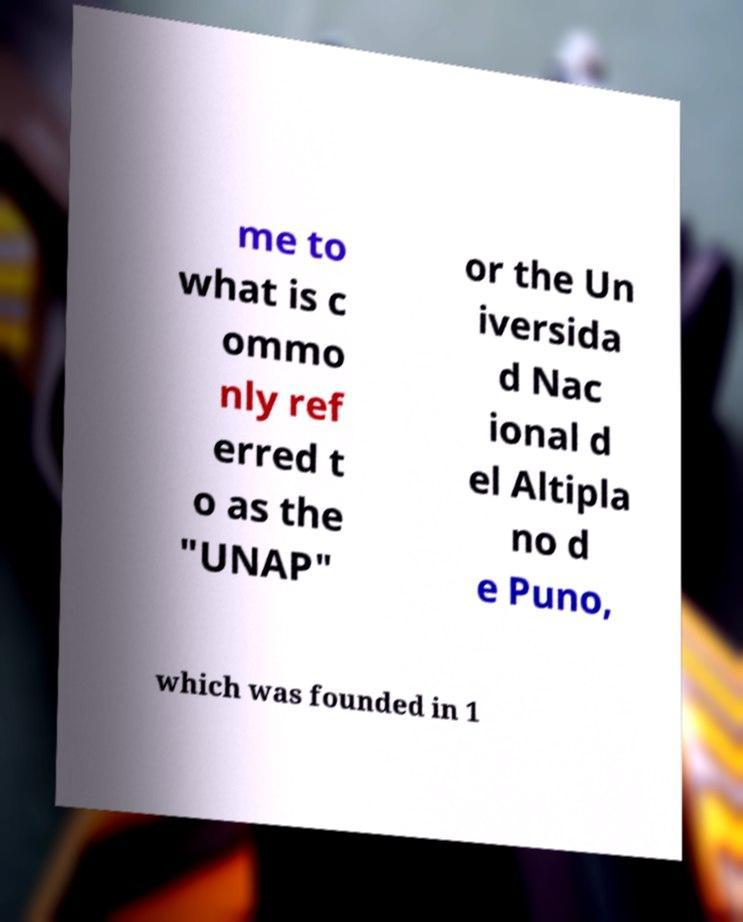What messages or text are displayed in this image? I need them in a readable, typed format. me to what is c ommo nly ref erred t o as the "UNAP" or the Un iversida d Nac ional d el Altipla no d e Puno, which was founded in 1 